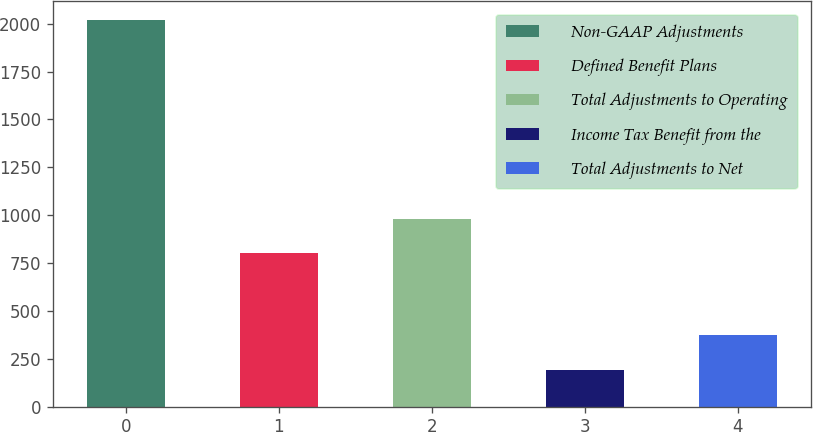Convert chart to OTSL. <chart><loc_0><loc_0><loc_500><loc_500><bar_chart><fcel>Non-GAAP Adjustments<fcel>Defined Benefit Plans<fcel>Total Adjustments to Operating<fcel>Income Tax Benefit from the<fcel>Total Adjustments to Net<nl><fcel>2017<fcel>800<fcel>982.4<fcel>193<fcel>375.4<nl></chart> 